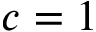<formula> <loc_0><loc_0><loc_500><loc_500>c = 1</formula> 